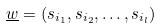Convert formula to latex. <formula><loc_0><loc_0><loc_500><loc_500>\underline { w } = ( s _ { i _ { 1 } } , s _ { i _ { 2 } } , \dots , s _ { i _ { l } } )</formula> 